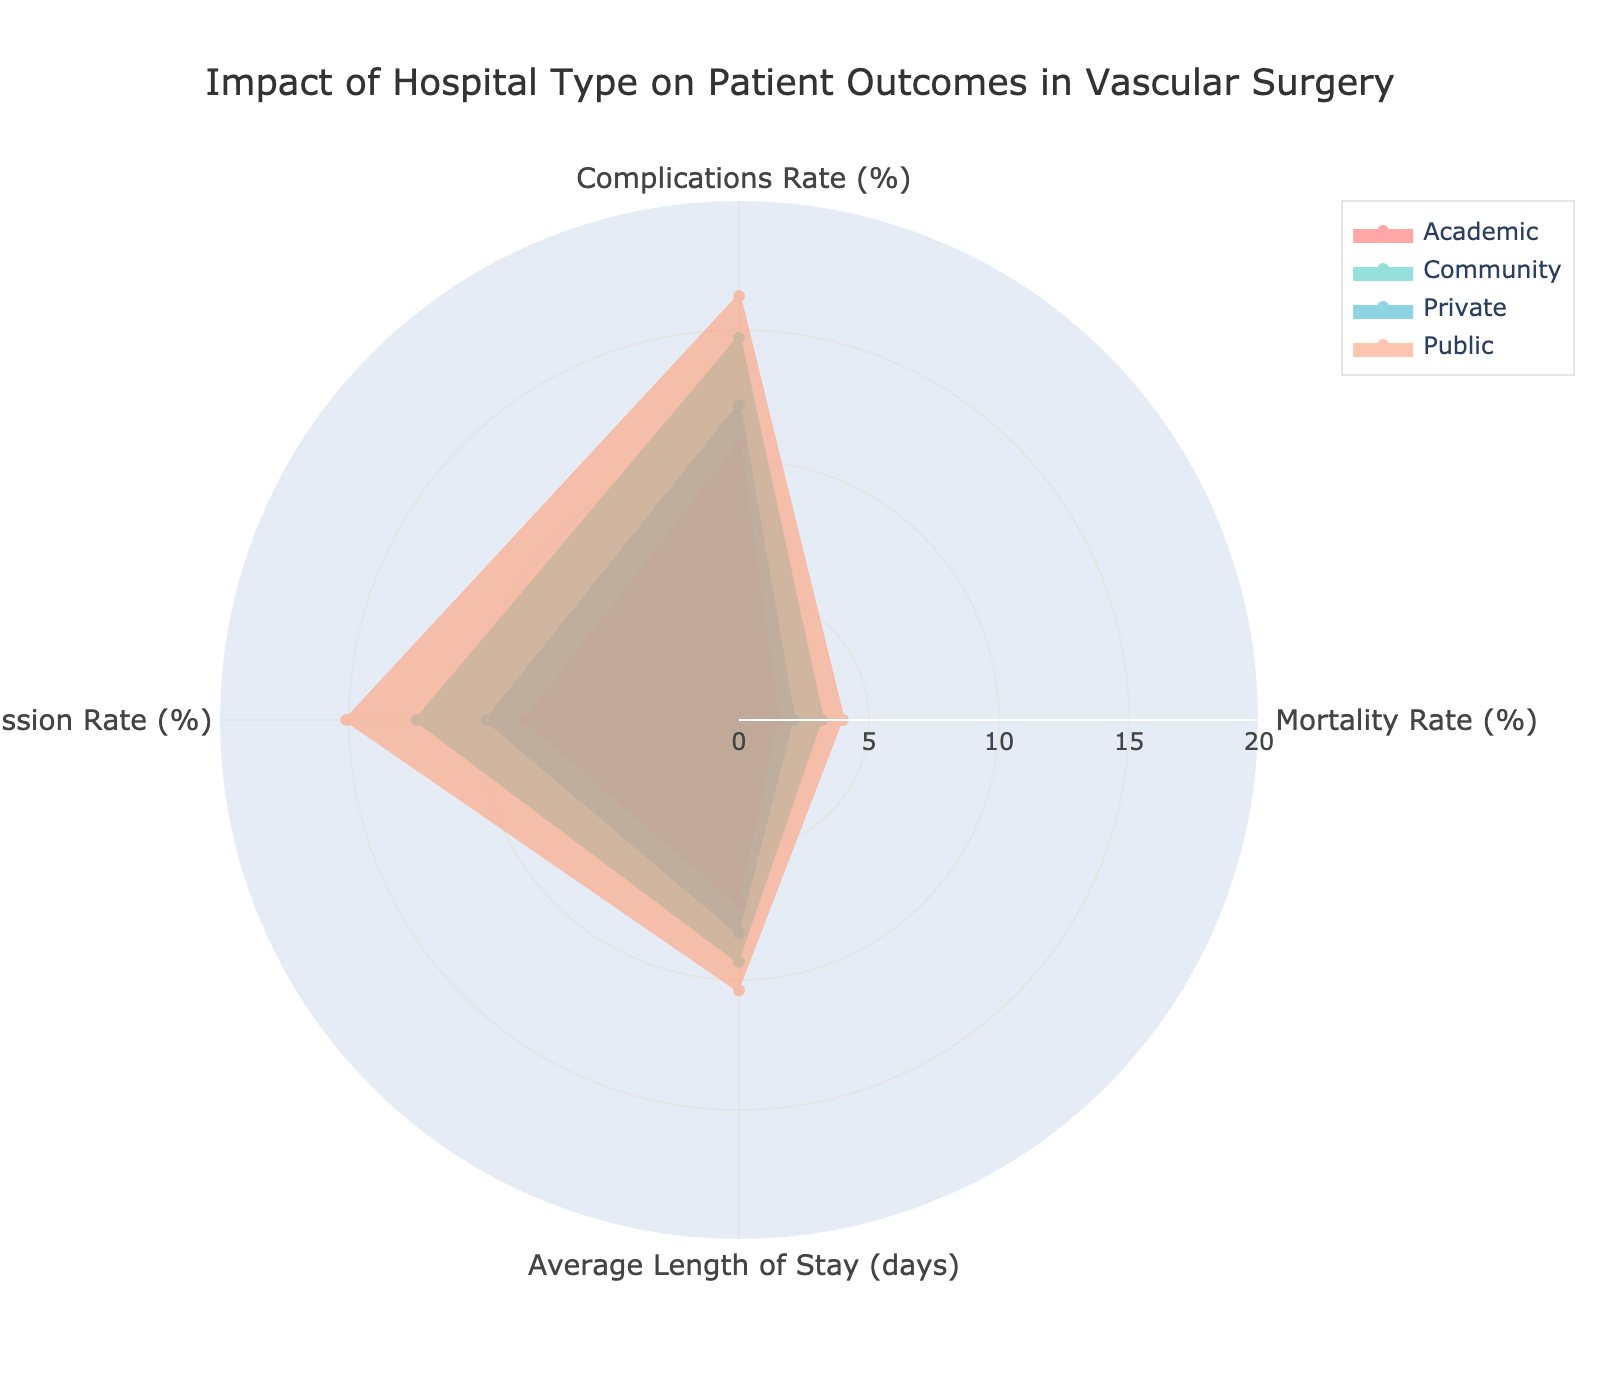What are the four hospital types shown in the chart? The chart displays four types of hospitals: Academic, Community, Private, and Public. They are marked by different colored lines and fill areas within the radar chart.
Answer: Academic, Community, Private, Public Which hospital type has the highest mortality rate? The Public hospital type reaches the maximum value on the Mortality Rate (%) axis compared to the other types.
Answer: Public What is the average readmission rate across all hospital types? The readmission rates for the four hospital types are 8.2, 12.4, 9.7, and 15.1. To find the average, add these values and divide by 4. The sum is 45.4, so the average readmission rate is 45.4 / 4.
Answer: 11.35 How does the complication rate of Academic hospitals compare to that of Community hospitals? The complication rates for Academic and Community hospitals are 10.6% and 14.7% respectively. Community hospitals have a higher complication rate by 4.1 percentage points.
Answer: Academic hospitals have a lower complication rate than Community hospitals by 4.1% Which hospital type has the lowest average length of stay? Based on the radar chart data, Academic hospitals have the lowest value for the Average Length of Stay (days), at 7.1 days.
Answer: Academic Compare the mortality rates of Academic and Private hospitals. The mortality rates for Academic and Private hospitals are 1.5% and 2.1% respectively. Therefore, Academic hospitals have a lower mortality rate than Private hospitals by 0.6 percentage points.
Answer: Academic hospitals have a lower mortality rate than Private hospitals In which two metrics do Private hospitals outperform Community hospitals? Analyzing the data on the radar chart, Private hospitals perform better than Community hospitals in Mortality Rate (2.1% vs. 3.2%) and Complications Rate (12.1% vs. 14.7%).
Answer: Mortality Rate and Complications Rate 